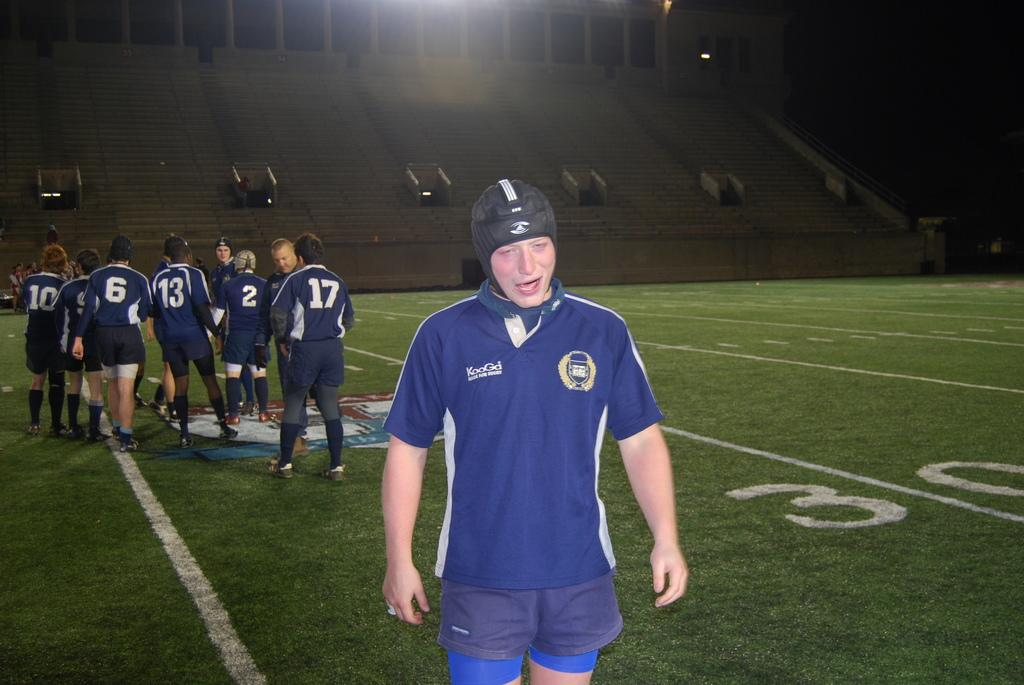<image>
Summarize the visual content of the image. Players 10, 6, 13, 2, and 17 remained on the field. 